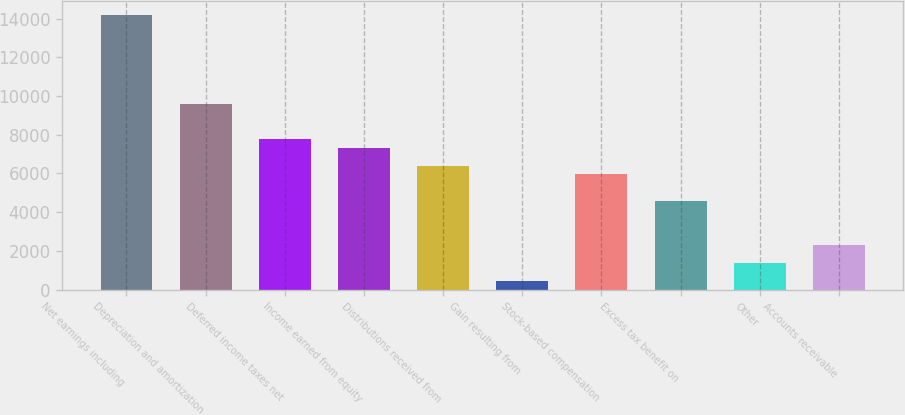Convert chart to OTSL. <chart><loc_0><loc_0><loc_500><loc_500><bar_chart><fcel>Net earnings including<fcel>Depreciation and amortization<fcel>Deferred income taxes net<fcel>Income earned from equity<fcel>Distributions received from<fcel>Gain resulting from<fcel>Stock-based compensation<fcel>Excess tax benefit on<fcel>Other<fcel>Accounts receivable<nl><fcel>14175.5<fcel>9603.86<fcel>7775.22<fcel>7318.06<fcel>6403.74<fcel>460.66<fcel>5946.58<fcel>4575.1<fcel>1374.98<fcel>2289.3<nl></chart> 